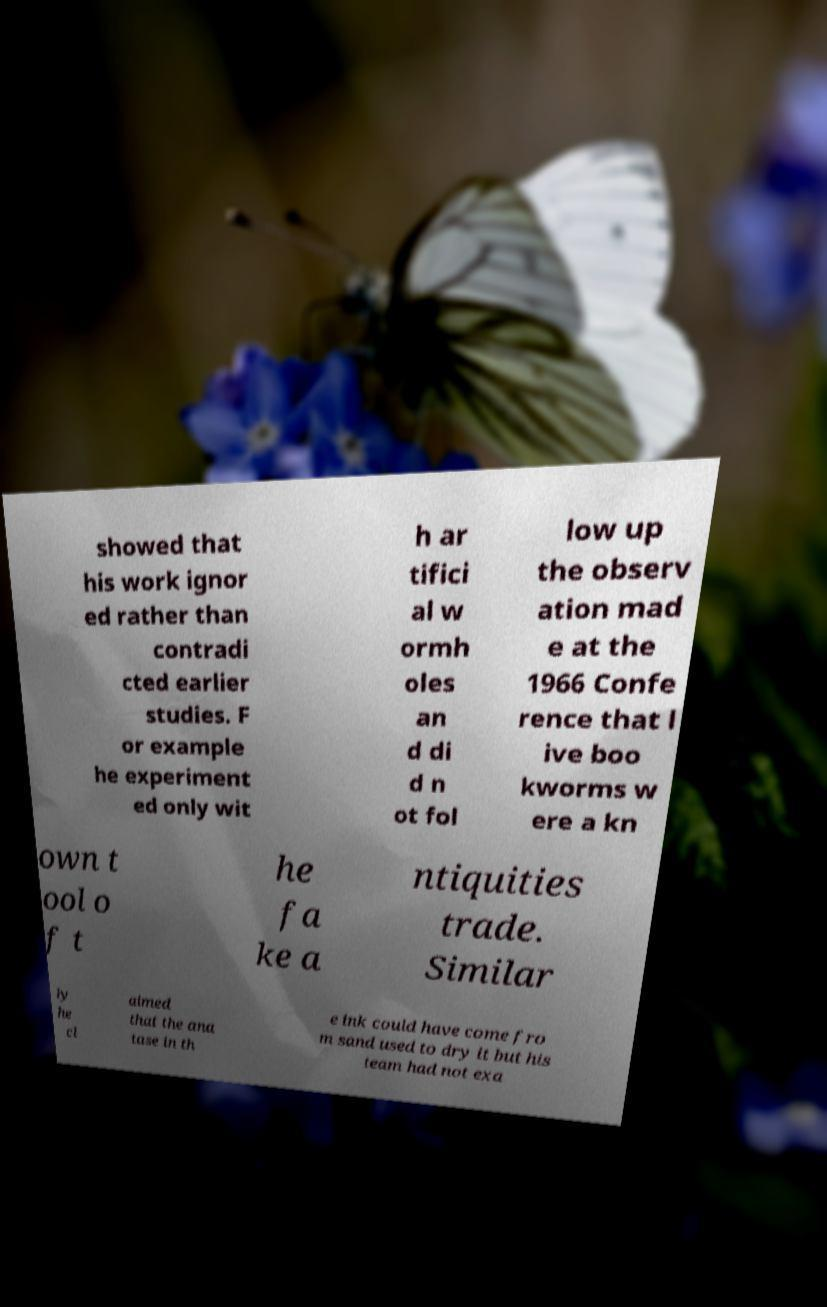Could you extract and type out the text from this image? showed that his work ignor ed rather than contradi cted earlier studies. F or example he experiment ed only wit h ar tifici al w ormh oles an d di d n ot fol low up the observ ation mad e at the 1966 Confe rence that l ive boo kworms w ere a kn own t ool o f t he fa ke a ntiquities trade. Similar ly he cl aimed that the ana tase in th e ink could have come fro m sand used to dry it but his team had not exa 